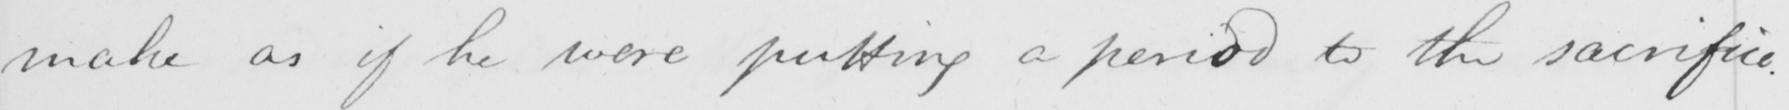Can you tell me what this handwritten text says? make as if he were putting a period to the sacrifice . 